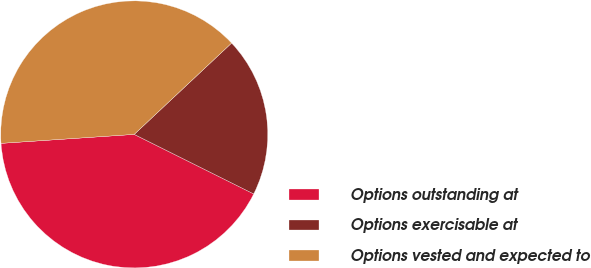<chart> <loc_0><loc_0><loc_500><loc_500><pie_chart><fcel>Options outstanding at<fcel>Options exercisable at<fcel>Options vested and expected to<nl><fcel>41.57%<fcel>19.35%<fcel>39.08%<nl></chart> 